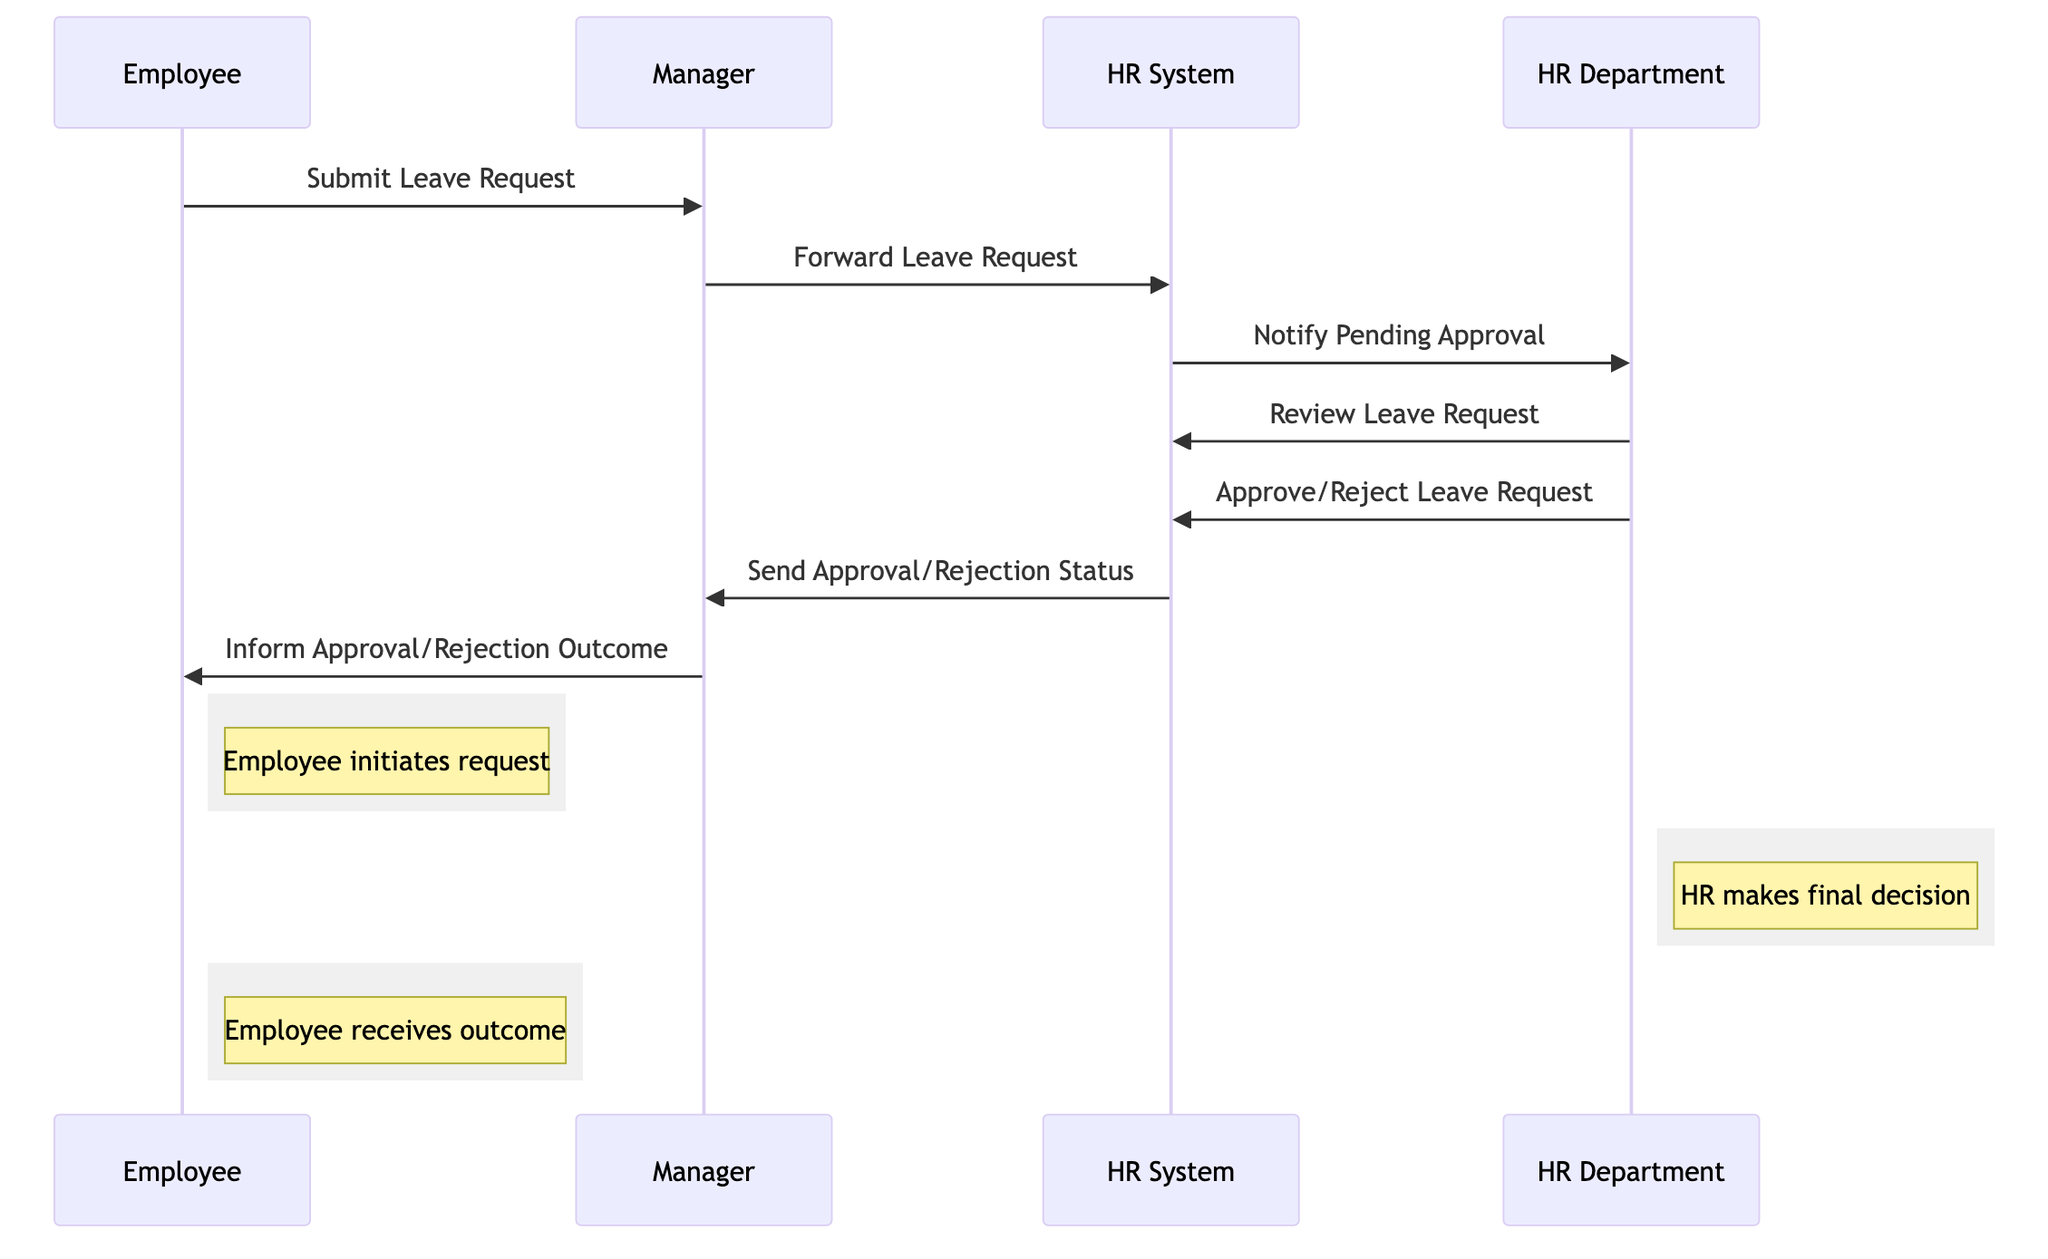What is the first action taken in the sequence? The first action is initiated by the Employee who submits a leave request to the Manager. This is the first message in the sequence of interactions.
Answer: Submit Leave Request How many participants are involved in the leave request workflow? The diagram has four participants: Employee, Manager, HR Department, and HR System, as evident from the list of actors included in the diagram.
Answer: Four What action does the HR Department take after reviewing the leave request? After reviewing, the HR Department takes the action to approve or reject the leave request as indicated in the sequence of actions that follows the review.
Answer: Approve/Reject Leave Request Which participant informs the Employee about the outcome? The Manager is responsible for informing the Employee about the approval or rejection outcome after receiving the status from the HR System.
Answer: Manager What type of response does the HR System send to the Manager? The HR System sends either an approval or rejection status back to the Manager, which represents the feedback from the HR Department's decision on the leave request.
Answer: Send Approval/Rejection Status How many messages are sent in total throughout the process? There are a total of seven messages that are exchanged between the participants in the process, as detailed in the sequence diagram.
Answer: Seven Identify the node that makes the final decision in the workflow. The HR Department makes the final decision on the employee's leave request, which follows the review and leads to the approval or rejection action.
Answer: HR Department What action follows the notification of pending approval by the HR System? After the HR System notifies the HR Department of a pending approval, the HR Department follows this with the review of the leave request, indicating that the next step in the process is the review.
Answer: Review Leave Request What does the employee receive after the Manager informs them? After the Manager informs the Employee, they receive the outcome of their leave request, which can either be approval or rejection depending on the preceding actions.
Answer: Outcome 